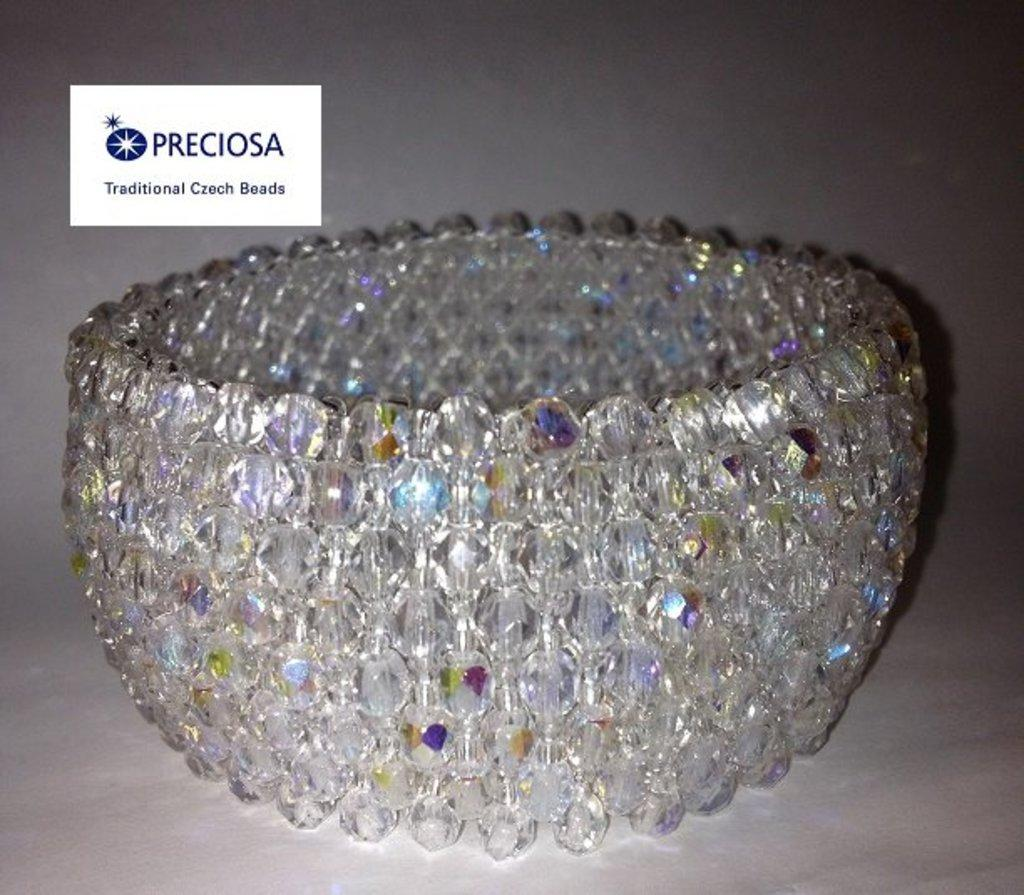What is the main object in the center of the image? There is a bangle in the center of the image. What can be found on the left side of the image? There is text on the left side of the image. What is the color of the surface in the image? The image has a white surface. How many eggs are visible in the image? There are no eggs present in the image. What type of note is attached to the bangle in the image? There is no note attached to the bangle in the image; only the bangle and text are present. 